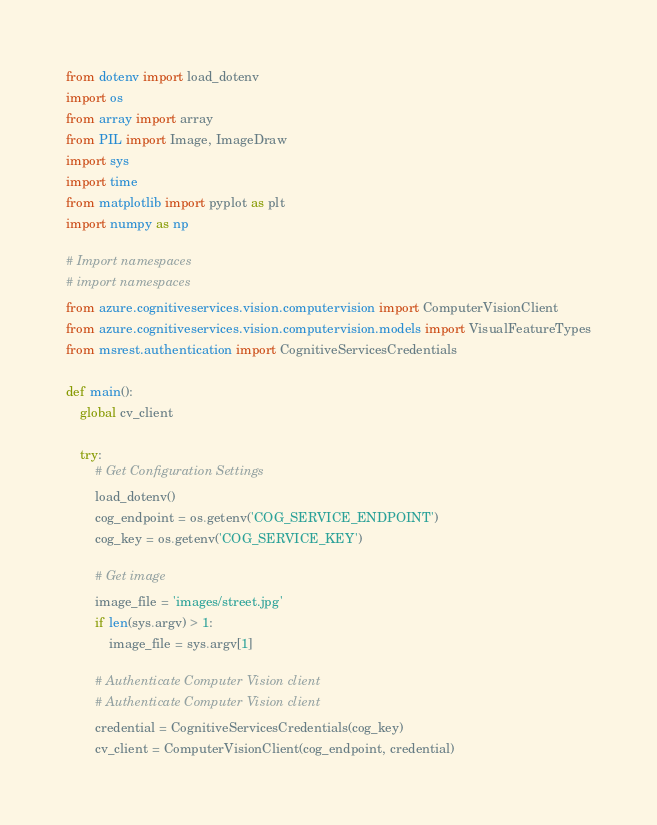<code> <loc_0><loc_0><loc_500><loc_500><_Python_>from dotenv import load_dotenv
import os
from array import array
from PIL import Image, ImageDraw
import sys
import time
from matplotlib import pyplot as plt
import numpy as np

# Import namespaces
# import namespaces
from azure.cognitiveservices.vision.computervision import ComputerVisionClient
from azure.cognitiveservices.vision.computervision.models import VisualFeatureTypes
from msrest.authentication import CognitiveServicesCredentials

def main():
    global cv_client

    try:
        # Get Configuration Settings
        load_dotenv()
        cog_endpoint = os.getenv('COG_SERVICE_ENDPOINT')
        cog_key = os.getenv('COG_SERVICE_KEY')

        # Get image
        image_file = 'images/street.jpg'
        if len(sys.argv) > 1:
            image_file = sys.argv[1]

        # Authenticate Computer Vision client
        # Authenticate Computer Vision client
        credential = CognitiveServicesCredentials(cog_key) 
        cv_client = ComputerVisionClient(cog_endpoint, credential)
</code> 